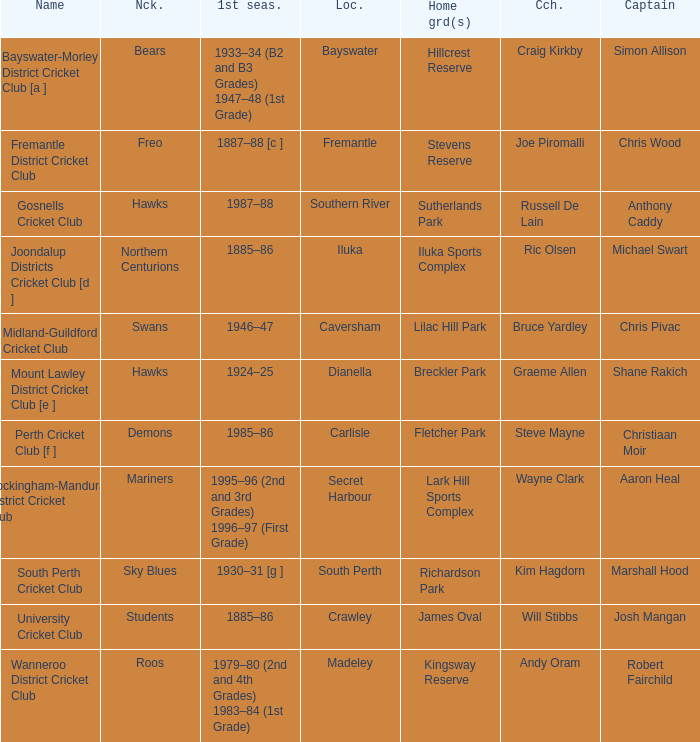With the nickname the swans, what is the home ground? Lilac Hill Park. 